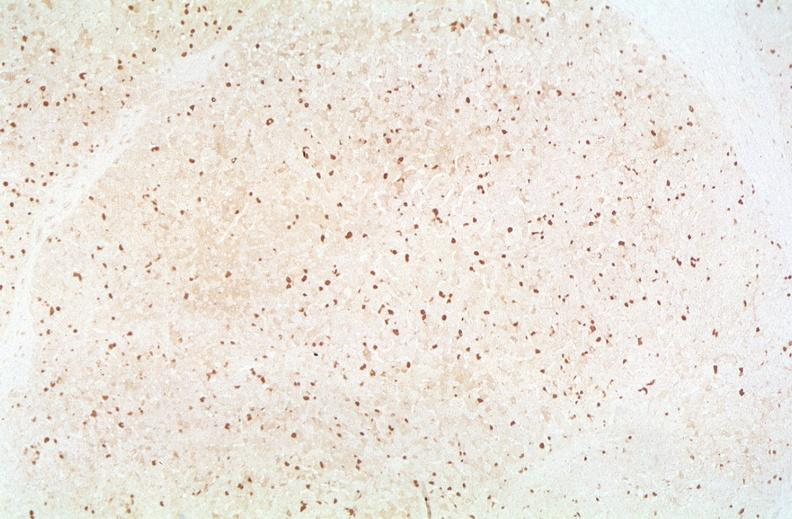s hepatobiliary present?
Answer the question using a single word or phrase. Yes 